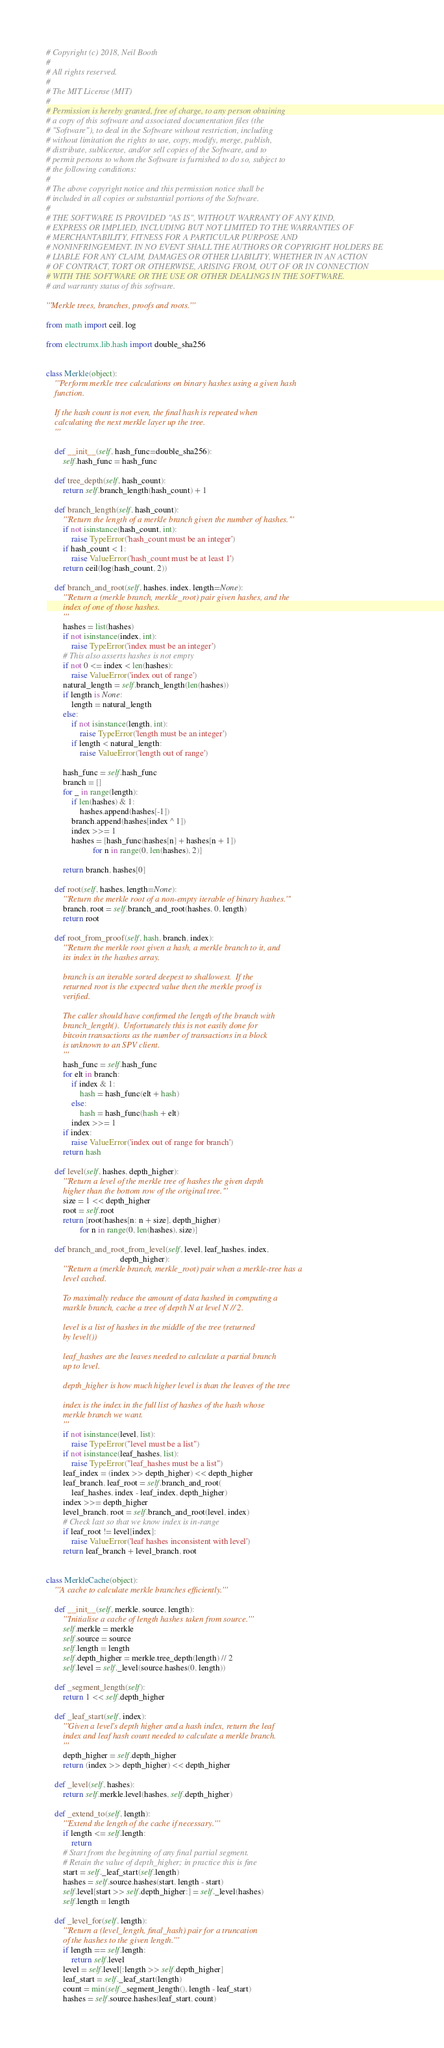<code> <loc_0><loc_0><loc_500><loc_500><_Python_># Copyright (c) 2018, Neil Booth
#
# All rights reserved.
#
# The MIT License (MIT)
#
# Permission is hereby granted, free of charge, to any person obtaining
# a copy of this software and associated documentation files (the
# "Software"), to deal in the Software without restriction, including
# without limitation the rights to use, copy, modify, merge, publish,
# distribute, sublicense, and/or sell copies of the Software, and to
# permit persons to whom the Software is furnished to do so, subject to
# the following conditions:
#
# The above copyright notice and this permission notice shall be
# included in all copies or substantial portions of the Software.
#
# THE SOFTWARE IS PROVIDED "AS IS", WITHOUT WARRANTY OF ANY KIND,
# EXPRESS OR IMPLIED, INCLUDING BUT NOT LIMITED TO THE WARRANTIES OF
# MERCHANTABILITY, FITNESS FOR A PARTICULAR PURPOSE AND
# NONINFRINGEMENT. IN NO EVENT SHALL THE AUTHORS OR COPYRIGHT HOLDERS BE
# LIABLE FOR ANY CLAIM, DAMAGES OR OTHER LIABILITY, WHETHER IN AN ACTION
# OF CONTRACT, TORT OR OTHERWISE, ARISING FROM, OUT OF OR IN CONNECTION
# WITH THE SOFTWARE OR THE USE OR OTHER DEALINGS IN THE SOFTWARE.
# and warranty status of this software.

'''Merkle trees, branches, proofs and roots.'''

from math import ceil, log

from electrumx.lib.hash import double_sha256


class Merkle(object):
    '''Perform merkle tree calculations on binary hashes using a given hash
    function.

    If the hash count is not even, the final hash is repeated when
    calculating the next merkle layer up the tree.
    '''

    def __init__(self, hash_func=double_sha256):
        self.hash_func = hash_func

    def tree_depth(self, hash_count):
        return self.branch_length(hash_count) + 1

    def branch_length(self, hash_count):
        '''Return the length of a merkle branch given the number of hashes.'''
        if not isinstance(hash_count, int):
            raise TypeError('hash_count must be an integer')
        if hash_count < 1:
            raise ValueError('hash_count must be at least 1')
        return ceil(log(hash_count, 2))

    def branch_and_root(self, hashes, index, length=None):
        '''Return a (merkle branch, merkle_root) pair given hashes, and the
        index of one of those hashes.
        '''
        hashes = list(hashes)
        if not isinstance(index, int):
            raise TypeError('index must be an integer')
        # This also asserts hashes is not empty
        if not 0 <= index < len(hashes):
            raise ValueError('index out of range')
        natural_length = self.branch_length(len(hashes))
        if length is None:
            length = natural_length
        else:
            if not isinstance(length, int):
                raise TypeError('length must be an integer')
            if length < natural_length:
                raise ValueError('length out of range')

        hash_func = self.hash_func
        branch = []
        for _ in range(length):
            if len(hashes) & 1:
                hashes.append(hashes[-1])
            branch.append(hashes[index ^ 1])
            index >>= 1
            hashes = [hash_func(hashes[n] + hashes[n + 1])
                      for n in range(0, len(hashes), 2)]

        return branch, hashes[0]

    def root(self, hashes, length=None):
        '''Return the merkle root of a non-empty iterable of binary hashes.'''
        branch, root = self.branch_and_root(hashes, 0, length)
        return root

    def root_from_proof(self, hash, branch, index):
        '''Return the merkle root given a hash, a merkle branch to it, and
        its index in the hashes array.

        branch is an iterable sorted deepest to shallowest.  If the
        returned root is the expected value then the merkle proof is
        verified.

        The caller should have confirmed the length of the branch with
        branch_length().  Unfortunately this is not easily done for
        bitcoin transactions as the number of transactions in a block
        is unknown to an SPV client.
        '''
        hash_func = self.hash_func
        for elt in branch:
            if index & 1:
                hash = hash_func(elt + hash)
            else:
                hash = hash_func(hash + elt)
            index >>= 1
        if index:
            raise ValueError('index out of range for branch')
        return hash

    def level(self, hashes, depth_higher):
        '''Return a level of the merkle tree of hashes the given depth
        higher than the bottom row of the original tree.'''
        size = 1 << depth_higher
        root = self.root
        return [root(hashes[n: n + size], depth_higher)
                for n in range(0, len(hashes), size)]

    def branch_and_root_from_level(self, level, leaf_hashes, index,
                                   depth_higher):
        '''Return a (merkle branch, merkle_root) pair when a merkle-tree has a
        level cached.

        To maximally reduce the amount of data hashed in computing a
        markle branch, cache a tree of depth N at level N // 2.

        level is a list of hashes in the middle of the tree (returned
        by level())

        leaf_hashes are the leaves needed to calculate a partial branch
        up to level.

        depth_higher is how much higher level is than the leaves of the tree

        index is the index in the full list of hashes of the hash whose
        merkle branch we want.
        '''
        if not isinstance(level, list):
            raise TypeError("level must be a list")
        if not isinstance(leaf_hashes, list):
            raise TypeError("leaf_hashes must be a list")
        leaf_index = (index >> depth_higher) << depth_higher
        leaf_branch, leaf_root = self.branch_and_root(
            leaf_hashes, index - leaf_index, depth_higher)
        index >>= depth_higher
        level_branch, root = self.branch_and_root(level, index)
        # Check last so that we know index is in-range
        if leaf_root != level[index]:
            raise ValueError('leaf hashes inconsistent with level')
        return leaf_branch + level_branch, root


class MerkleCache(object):
    '''A cache to calculate merkle branches efficiently.'''

    def __init__(self, merkle, source, length):
        '''Initialise a cache of length hashes taken from source.'''
        self.merkle = merkle
        self.source = source
        self.length = length
        self.depth_higher = merkle.tree_depth(length) // 2
        self.level = self._level(source.hashes(0, length))

    def _segment_length(self):
        return 1 << self.depth_higher

    def _leaf_start(self, index):
        '''Given a level's depth higher and a hash index, return the leaf
        index and leaf hash count needed to calculate a merkle branch.
        '''
        depth_higher = self.depth_higher
        return (index >> depth_higher) << depth_higher

    def _level(self, hashes):
        return self.merkle.level(hashes, self.depth_higher)

    def _extend_to(self, length):
        '''Extend the length of the cache if necessary.'''
        if length <= self.length:
            return
        # Start from the beginning of any final partial segment.
        # Retain the value of depth_higher; in practice this is fine
        start = self._leaf_start(self.length)
        hashes = self.source.hashes(start, length - start)
        self.level[start >> self.depth_higher:] = self._level(hashes)
        self.length = length

    def _level_for(self, length):
        '''Return a (level_length, final_hash) pair for a truncation
        of the hashes to the given length.'''
        if length == self.length:
            return self.level
        level = self.level[:length >> self.depth_higher]
        leaf_start = self._leaf_start(length)
        count = min(self._segment_length(), length - leaf_start)
        hashes = self.source.hashes(leaf_start, count)</code> 